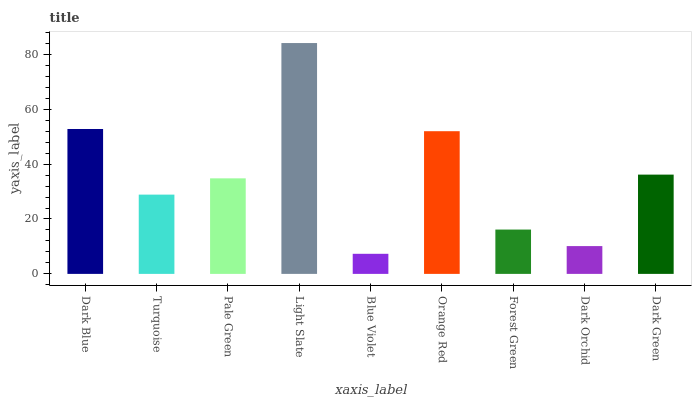Is Blue Violet the minimum?
Answer yes or no. Yes. Is Light Slate the maximum?
Answer yes or no. Yes. Is Turquoise the minimum?
Answer yes or no. No. Is Turquoise the maximum?
Answer yes or no. No. Is Dark Blue greater than Turquoise?
Answer yes or no. Yes. Is Turquoise less than Dark Blue?
Answer yes or no. Yes. Is Turquoise greater than Dark Blue?
Answer yes or no. No. Is Dark Blue less than Turquoise?
Answer yes or no. No. Is Pale Green the high median?
Answer yes or no. Yes. Is Pale Green the low median?
Answer yes or no. Yes. Is Orange Red the high median?
Answer yes or no. No. Is Dark Blue the low median?
Answer yes or no. No. 